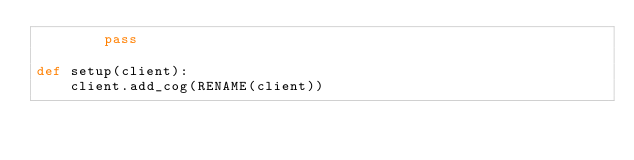<code> <loc_0><loc_0><loc_500><loc_500><_Python_>        pass

def setup(client):
    client.add_cog(RENAME(client))</code> 